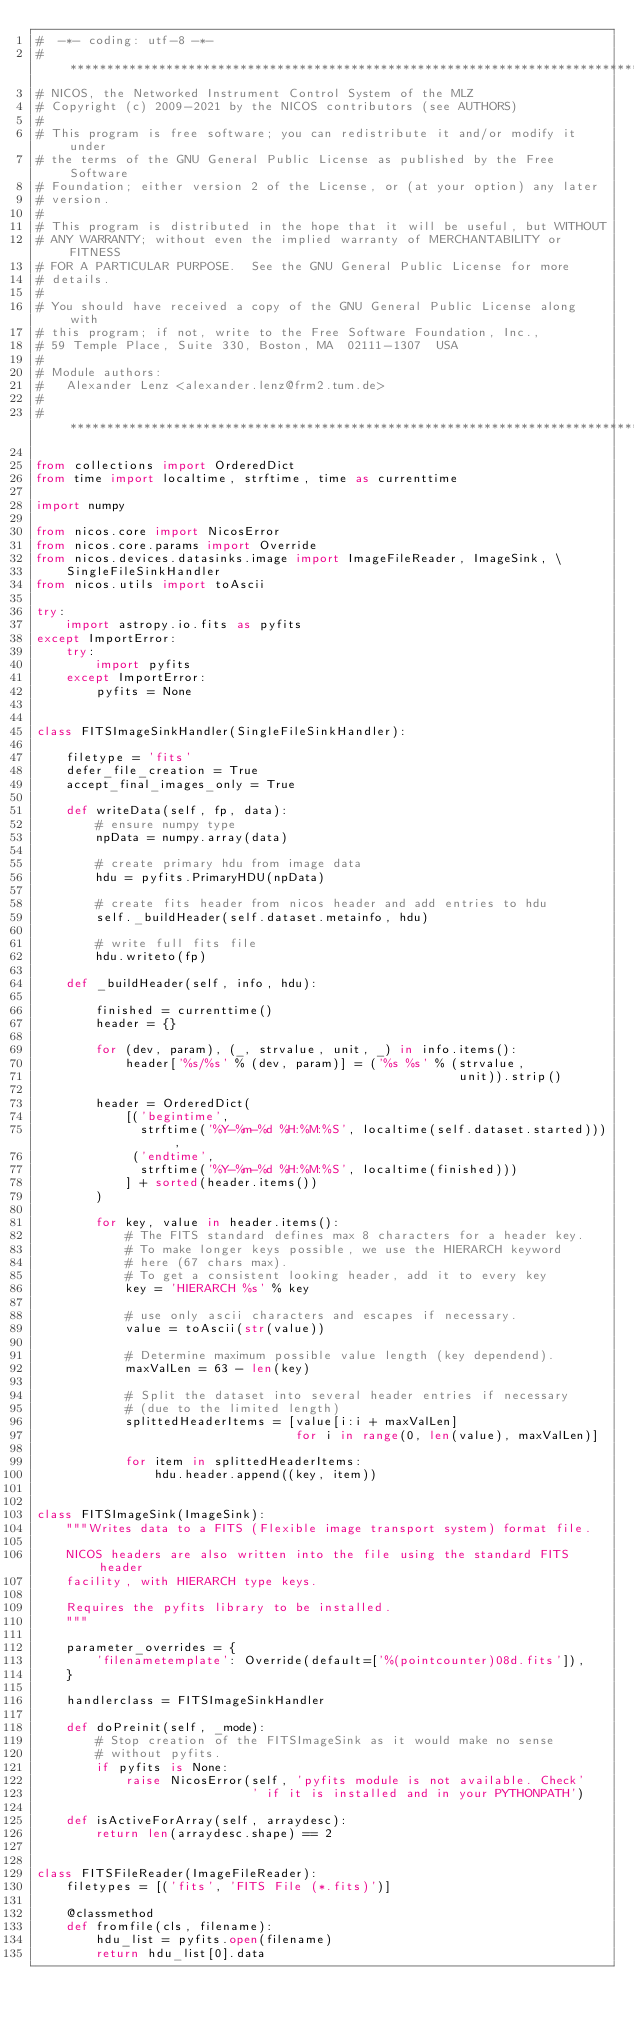Convert code to text. <code><loc_0><loc_0><loc_500><loc_500><_Python_>#  -*- coding: utf-8 -*-
# *****************************************************************************
# NICOS, the Networked Instrument Control System of the MLZ
# Copyright (c) 2009-2021 by the NICOS contributors (see AUTHORS)
#
# This program is free software; you can redistribute it and/or modify it under
# the terms of the GNU General Public License as published by the Free Software
# Foundation; either version 2 of the License, or (at your option) any later
# version.
#
# This program is distributed in the hope that it will be useful, but WITHOUT
# ANY WARRANTY; without even the implied warranty of MERCHANTABILITY or FITNESS
# FOR A PARTICULAR PURPOSE.  See the GNU General Public License for more
# details.
#
# You should have received a copy of the GNU General Public License along with
# this program; if not, write to the Free Software Foundation, Inc.,
# 59 Temple Place, Suite 330, Boston, MA  02111-1307  USA
#
# Module authors:
#   Alexander Lenz <alexander.lenz@frm2.tum.de>
#
# *****************************************************************************

from collections import OrderedDict
from time import localtime, strftime, time as currenttime

import numpy

from nicos.core import NicosError
from nicos.core.params import Override
from nicos.devices.datasinks.image import ImageFileReader, ImageSink, \
    SingleFileSinkHandler
from nicos.utils import toAscii

try:
    import astropy.io.fits as pyfits
except ImportError:
    try:
        import pyfits
    except ImportError:
        pyfits = None


class FITSImageSinkHandler(SingleFileSinkHandler):

    filetype = 'fits'
    defer_file_creation = True
    accept_final_images_only = True

    def writeData(self, fp, data):
        # ensure numpy type
        npData = numpy.array(data)

        # create primary hdu from image data
        hdu = pyfits.PrimaryHDU(npData)

        # create fits header from nicos header and add entries to hdu
        self._buildHeader(self.dataset.metainfo, hdu)

        # write full fits file
        hdu.writeto(fp)

    def _buildHeader(self, info, hdu):

        finished = currenttime()
        header = {}

        for (dev, param), (_, strvalue, unit, _) in info.items():
            header['%s/%s' % (dev, param)] = ('%s %s' % (strvalue,
                                                         unit)).strip()

        header = OrderedDict(
            [('begintime',
              strftime('%Y-%m-%d %H:%M:%S', localtime(self.dataset.started))),
             ('endtime',
              strftime('%Y-%m-%d %H:%M:%S', localtime(finished)))
            ] + sorted(header.items())
        )

        for key, value in header.items():
            # The FITS standard defines max 8 characters for a header key.
            # To make longer keys possible, we use the HIERARCH keyword
            # here (67 chars max).
            # To get a consistent looking header, add it to every key
            key = 'HIERARCH %s' % key

            # use only ascii characters and escapes if necessary.
            value = toAscii(str(value))

            # Determine maximum possible value length (key dependend).
            maxValLen = 63 - len(key)

            # Split the dataset into several header entries if necessary
            # (due to the limited length)
            splittedHeaderItems = [value[i:i + maxValLen]
                                   for i in range(0, len(value), maxValLen)]

            for item in splittedHeaderItems:
                hdu.header.append((key, item))


class FITSImageSink(ImageSink):
    """Writes data to a FITS (Flexible image transport system) format file.

    NICOS headers are also written into the file using the standard FITS header
    facility, with HIERARCH type keys.

    Requires the pyfits library to be installed.
    """

    parameter_overrides = {
        'filenametemplate': Override(default=['%(pointcounter)08d.fits']),
    }

    handlerclass = FITSImageSinkHandler

    def doPreinit(self, _mode):
        # Stop creation of the FITSImageSink as it would make no sense
        # without pyfits.
        if pyfits is None:
            raise NicosError(self, 'pyfits module is not available. Check'
                             ' if it is installed and in your PYTHONPATH')

    def isActiveForArray(self, arraydesc):
        return len(arraydesc.shape) == 2


class FITSFileReader(ImageFileReader):
    filetypes = [('fits', 'FITS File (*.fits)')]

    @classmethod
    def fromfile(cls, filename):
        hdu_list = pyfits.open(filename)
        return hdu_list[0].data
</code> 